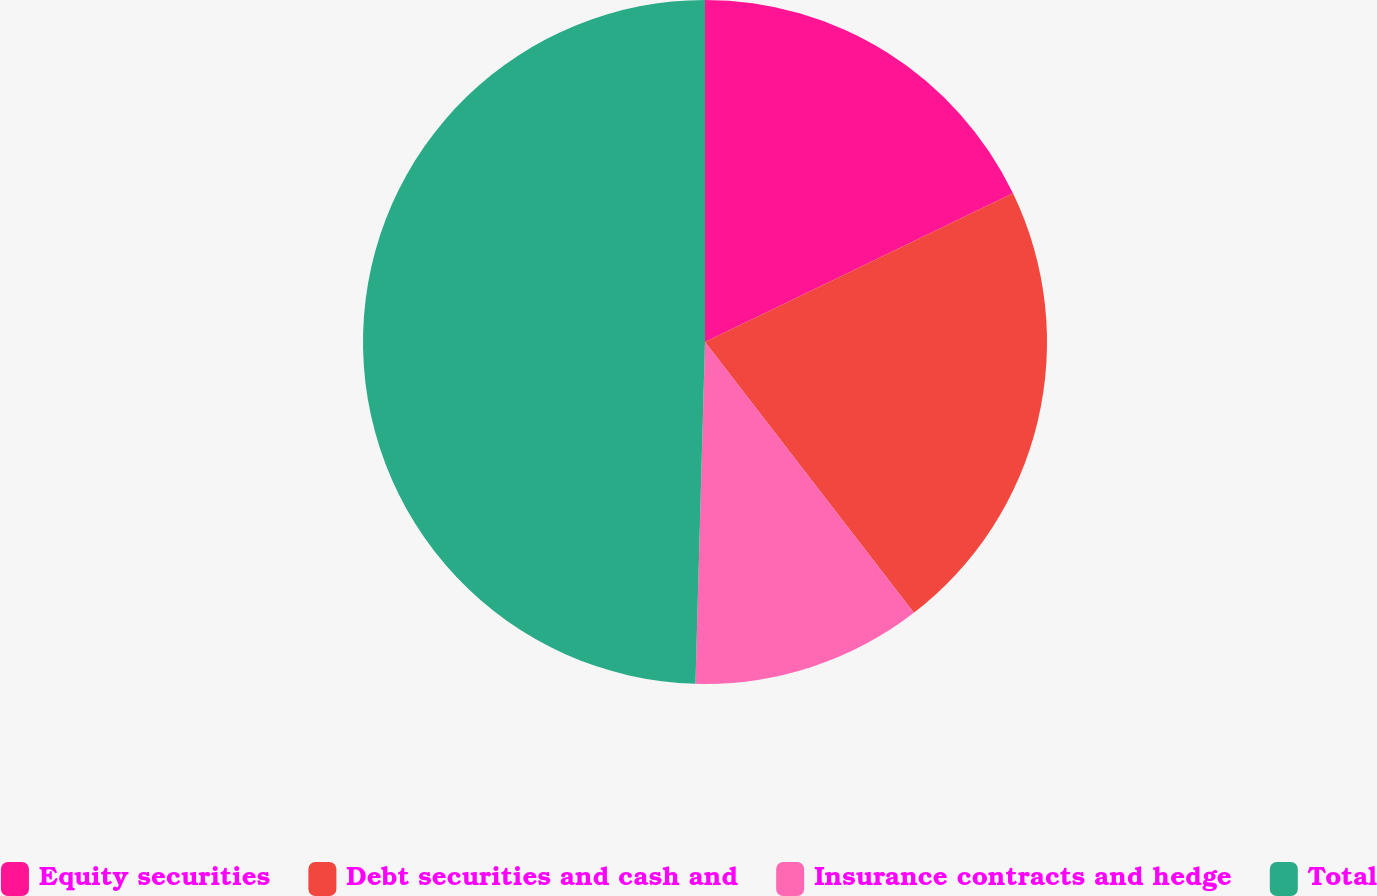<chart> <loc_0><loc_0><loc_500><loc_500><pie_chart><fcel>Equity securities<fcel>Debt securities and cash and<fcel>Insurance contracts and hedge<fcel>Total<nl><fcel>17.84%<fcel>21.7%<fcel>10.9%<fcel>49.55%<nl></chart> 